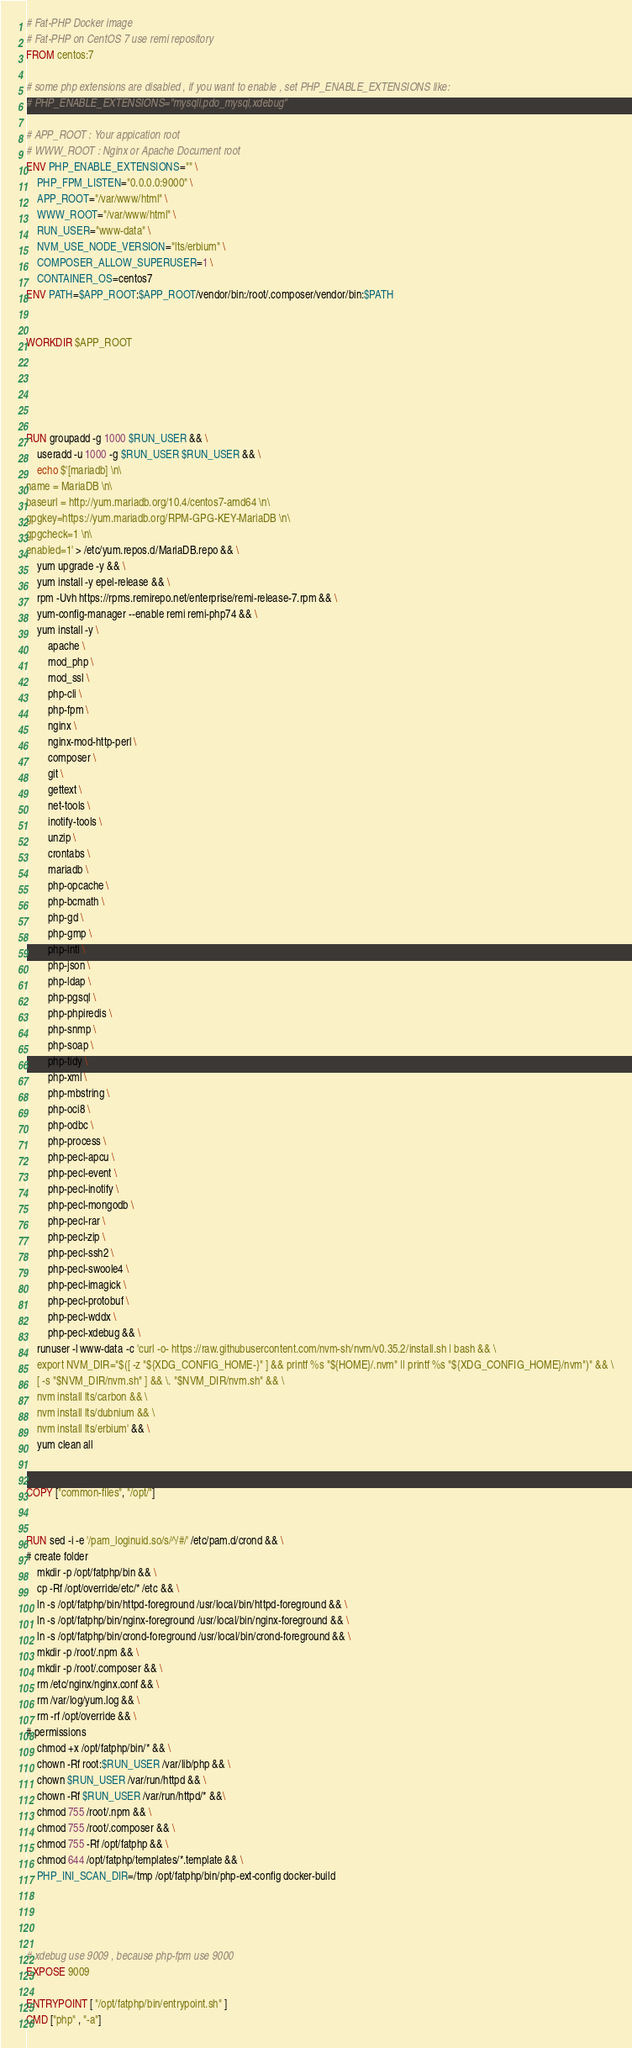<code> <loc_0><loc_0><loc_500><loc_500><_Dockerfile_># Fat-PHP Docker image
# Fat-PHP on CentOS 7 use remi repository
FROM centos:7

# some php extensions are disabled , if you want to enable , set PHP_ENABLE_EXTENSIONS like:
# PHP_ENABLE_EXTENSIONS="mysqli,pdo_mysql,xdebug"

# APP_ROOT : Your appication root
# WWW_ROOT : Nginx or Apache Document root
ENV PHP_ENABLE_EXTENSIONS="" \
    PHP_FPM_LISTEN="0.0.0.0:9000" \
    APP_ROOT="/var/www/html" \
    WWW_ROOT="/var/www/html" \
    RUN_USER="www-data" \
    NVM_USE_NODE_VERSION="lts/erbium" \
    COMPOSER_ALLOW_SUPERUSER=1 \
    CONTAINER_OS=centos7
ENV PATH=$APP_ROOT:$APP_ROOT/vendor/bin:/root/.composer/vendor/bin:$PATH


WORKDIR $APP_ROOT





RUN groupadd -g 1000 $RUN_USER && \
    useradd -u 1000 -g $RUN_USER $RUN_USER && \
    echo $'[mariadb] \n\
name = MariaDB \n\
baseurl = http://yum.mariadb.org/10.4/centos7-amd64 \n\
gpgkey=https://yum.mariadb.org/RPM-GPG-KEY-MariaDB \n\
gpgcheck=1 \n\
enabled=1' > /etc/yum.repos.d/MariaDB.repo && \
    yum upgrade -y && \
    yum install -y epel-release && \
	rpm -Uvh https://rpms.remirepo.net/enterprise/remi-release-7.rpm && \
	yum-config-manager --enable remi remi-php74 && \
    yum install -y \
        apache \
        mod_php \
        mod_ssl \
        php-cli \
        php-fpm \
        nginx \
        nginx-mod-http-perl \
        composer \
        git \
        gettext \
        net-tools \
        inotify-tools \
        unzip \
        crontabs \
        mariadb \
        php-opcache \
        php-bcmath \
        php-gd \
        php-gmp \
        php-intl \
        php-json \
        php-ldap \
        php-pgsql \
        php-phpiredis \
        php-snmp \
        php-soap \
        php-tidy \
        php-xml \
        php-mbstring \
        php-oci8 \
        php-odbc \
        php-process \
        php-pecl-apcu \
        php-pecl-event \
        php-pecl-inotify \
        php-pecl-mongodb \
        php-pecl-rar \
        php-pecl-zip \
        php-pecl-ssh2 \
        php-pecl-swoole4 \
        php-pecl-imagick \
        php-pecl-protobuf \
        php-pecl-wddx \
        php-pecl-xdebug && \
    runuser -l www-data -c 'curl -o- https://raw.githubusercontent.com/nvm-sh/nvm/v0.35.2/install.sh | bash && \
    export NVM_DIR="$([ -z "${XDG_CONFIG_HOME-}" ] && printf %s "${HOME}/.nvm" || printf %s "${XDG_CONFIG_HOME}/nvm")" && \
    [ -s "$NVM_DIR/nvm.sh" ] && \. "$NVM_DIR/nvm.sh" && \
    nvm install lts/carbon && \
    nvm install lts/dubnium && \
    nvm install lts/erbium' && \
    yum clean all


COPY ["common-files", "/opt/"]


RUN sed -i -e '/pam_loginuid.so/s/^/#/' /etc/pam.d/crond && \
# create folder
    mkdir -p /opt/fatphp/bin && \
    cp -Rf /opt/override/etc/* /etc && \
    ln -s /opt/fatphp/bin/httpd-foreground /usr/local/bin/httpd-foreground && \
    ln -s /opt/fatphp/bin/nginx-foreground /usr/local/bin/nginx-foreground && \
    ln -s /opt/fatphp/bin/crond-foreground /usr/local/bin/crond-foreground && \
    mkdir -p /root/.npm && \
    mkdir -p /root/.composer && \
    rm /etc/nginx/nginx.conf && \
    rm /var/log/yum.log && \
    rm -rf /opt/override && \
# permissions
    chmod +x /opt/fatphp/bin/* && \
    chown -Rf root:$RUN_USER /var/lib/php && \
    chown $RUN_USER /var/run/httpd && \
    chown -Rf $RUN_USER /var/run/httpd/* &&\
    chmod 755 /root/.npm && \
    chmod 755 /root/.composer && \
    chmod 755 -Rf /opt/fatphp && \
    chmod 644 /opt/fatphp/templates/*.template && \
    PHP_INI_SCAN_DIR=/tmp /opt/fatphp/bin/php-ext-config docker-build




# xdebug use 9009 , because php-fpm use 9000
EXPOSE 9009

ENTRYPOINT [ "/opt/fatphp/bin/entrypoint.sh" ]
CMD ["php" , "-a"]</code> 